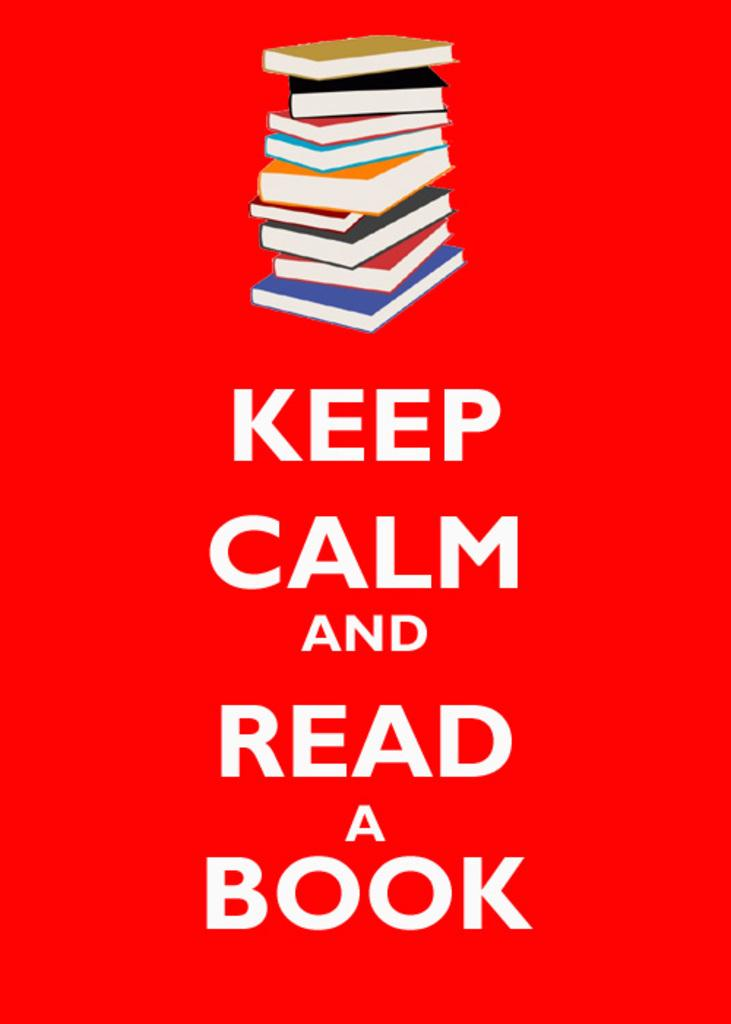<image>
Relay a brief, clear account of the picture shown. A pile of books stacked up sit on a sign above the wording keep calm and read. 